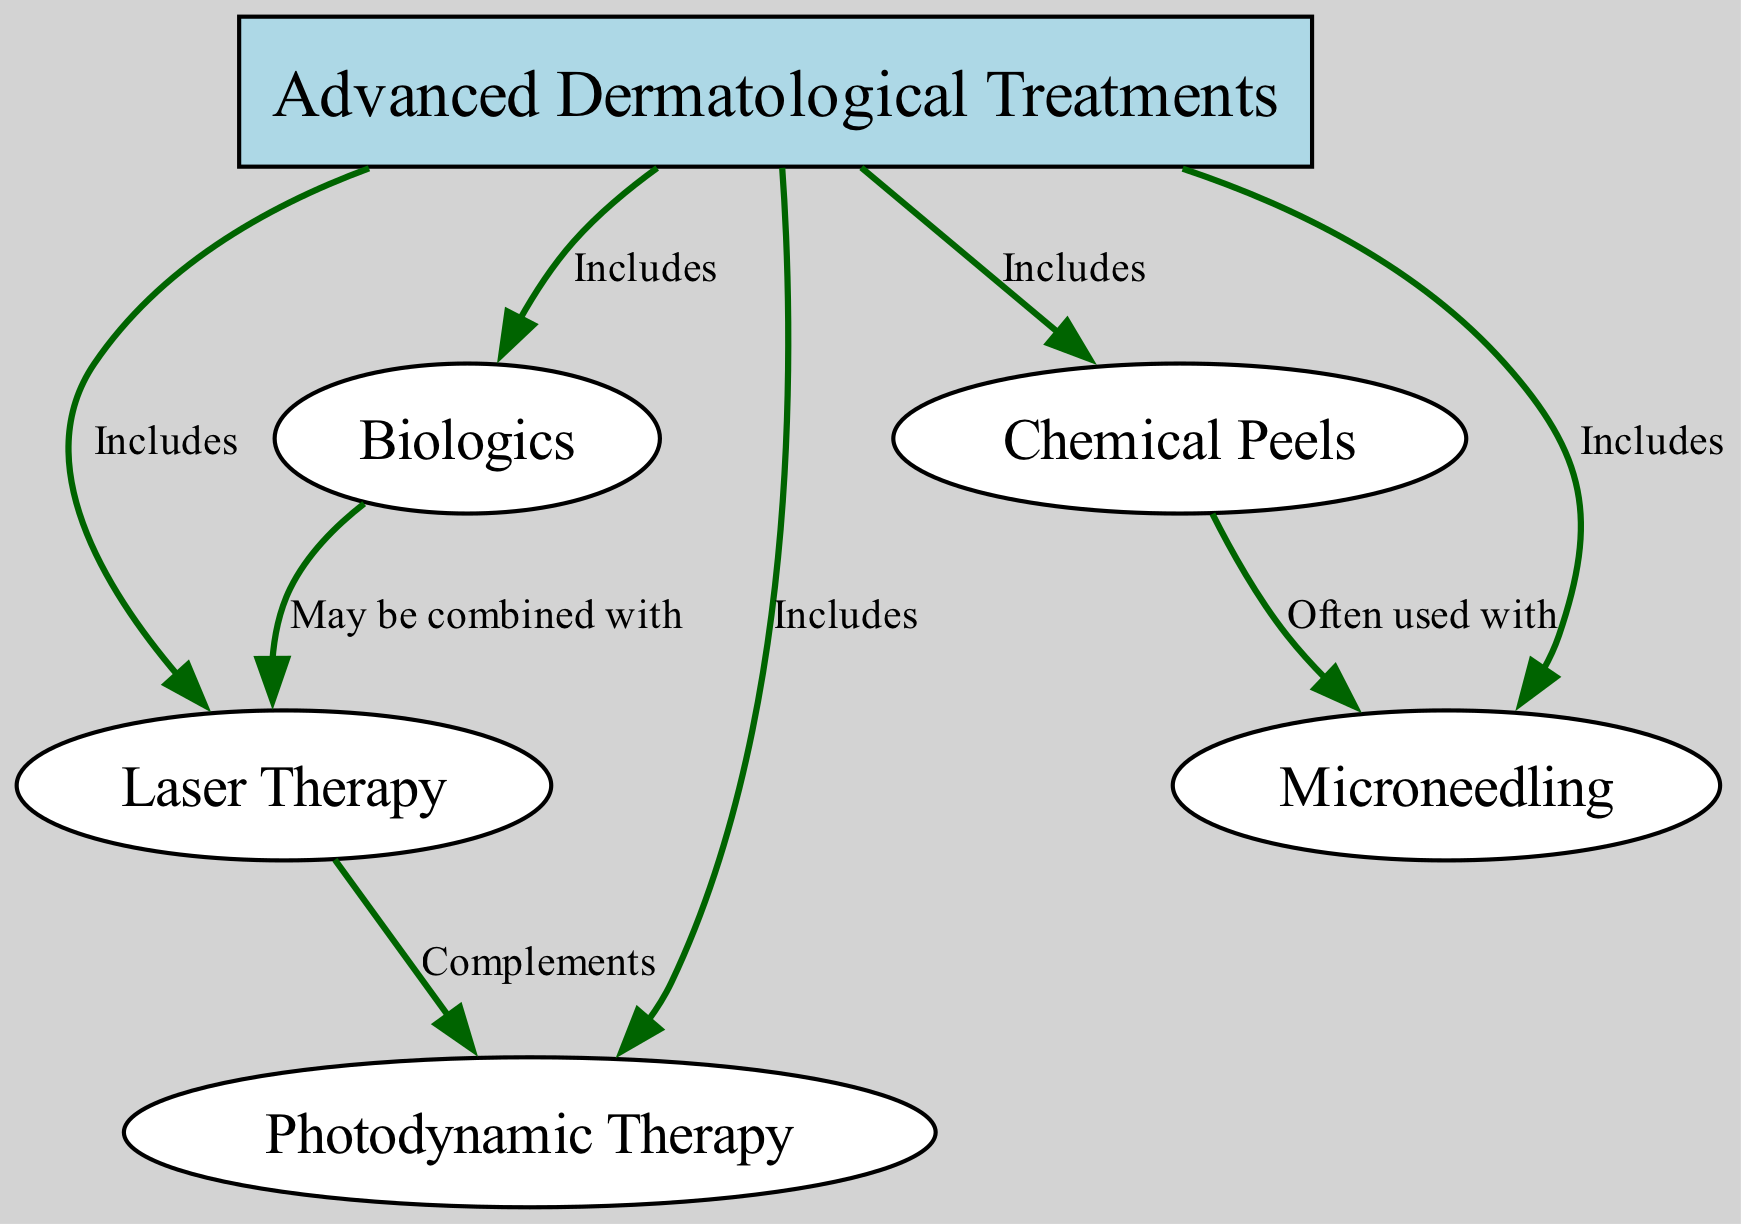What are the three main components of Advanced Dermatological Treatments? The diagram shows that Advanced Dermatological Treatments includes Laser Therapy, Biologics, Photodynamic Therapy, Chemical Peels, and Microneedling. The three main treatments mentioned directly under Advanced Dermatological Treatments are Laser Therapy, Biologics, and Photodynamic Therapy.
Answer: Laser Therapy, Biologics, Photodynamic Therapy How many nodes are in the diagram? In the diagram, there are a total of 6 nodes representing different treatments and their relationships. These are Advanced Dermatological Treatments, Laser Therapy, Biologics, Photodynamic Therapy, Chemical Peels, and Microneedling.
Answer: 6 What treatment complements Laser Therapy? According to the diagram, Photodynamic Therapy is shown to complement Laser Therapy. This is indicated by the edge connecting these two nodes with the label "Complements."
Answer: Photodynamic Therapy Which two treatments are often used together? The diagram indicates that Chemical Peels and Microneedling are often used together, as shown by the edge connecting these two nodes with the label "Often used with."
Answer: Chemical Peels, Microneedling Which treatment can be combined with Biologics? The diagram specifies that Laser Therapy may be combined with Biologics, reflected by the edge connecting these nodes labeled "May be combined with."
Answer: Laser Therapy 